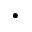<formula> <loc_0><loc_0><loc_500><loc_500>\cdot</formula> 